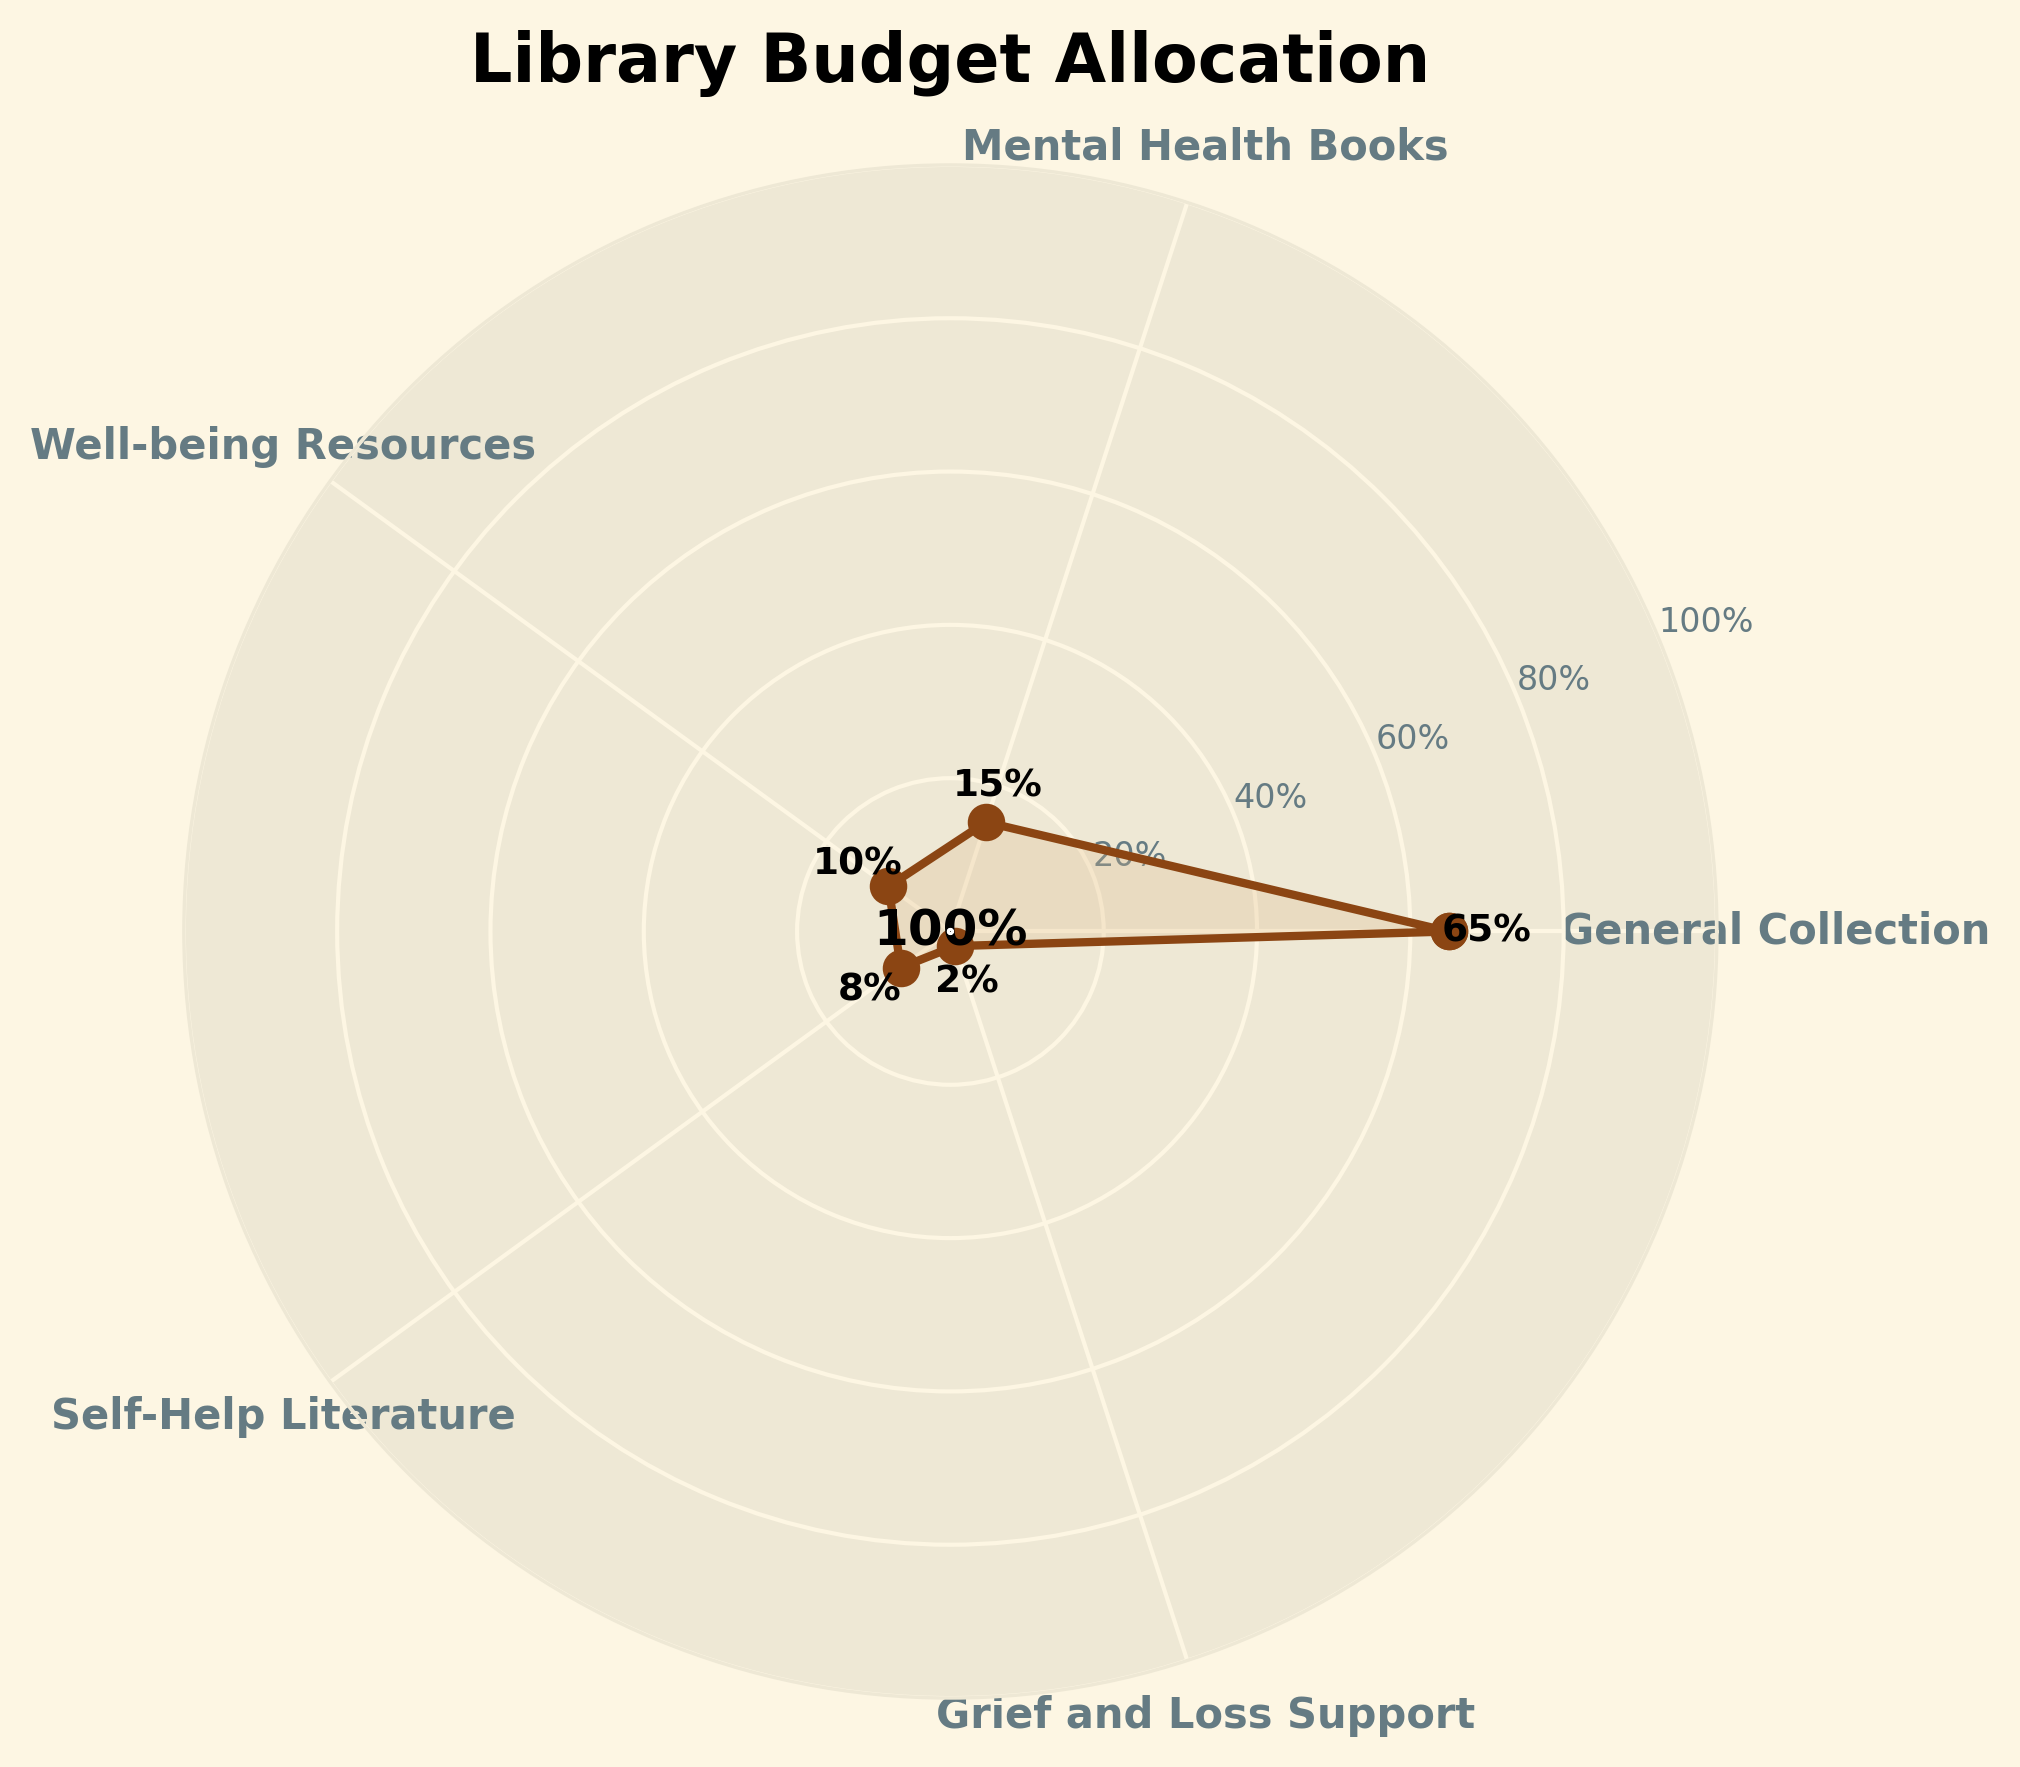What percentage of the library's budget is allocated to Mental Health Books? According to the figure, the percentage label next to "Mental Health Books" indicates the budget allocation.
Answer: 15% How much of the budget is allocated to Self-Help Literature compared to Grief and Loss Support? By comparing the percentage labels for Self-Help Literature (8%) and Grief and Loss Support (2%), we see that Self-Help Literature receives a greater percentage.
Answer: 6% more What is the total percentage of the budget allocated to categories specifically related to mental health and well-being? Sum the percentages for Mental Health Books (15%), Well-being Resources (10%), Self-Help Literature (8%), and Grief and Loss Support (2%). The total is \( 15 + 10 + 8 + 2 = 35 \)%
Answer: 35% Which category receives the majority of the library's budget? The figure shows that the category with the highest percentage label is the General Collection, which is 65%.
Answer: General Collection What is the smallest budget allocation category, and what percentage does it receive? According to the figure, the smallest percentage label is next to "Grief and Loss Support" at 2%.
Answer: Grief and Loss Support, 2% How does the allocation for Well-being Resources compare to that for Mental Health Books? By comparing the percentages, Well-being Resources (10%) receives 5% less than Mental Health Books (15%).
Answer: 5% less Which two categories have the closest budget allocations? By comparing the percentages, the closest figures are for Self-Help Literature (8%) and Well-being Resources (10%), a difference of 2%.
Answer: Self-Help Literature and Well-being Resources If we double the percentage of the Grief and Loss Support, how would it compare to the percentage for Self-Help Literature? Doubling Grief and Loss Support \(2 \times 2 = 4\)% would still be less than the Self-Help Literature's 8%.
Answer: Still less What is the angle in radians for well-being resources if the total allocation is represented in a 2π radians circle? The angle for Well-being Resources is calculated as \( \frac{10}{100} \times 2\pi = 0.2\pi \) radians.
Answer: \(0.2\pi\) Based on the visual elements, where is the overall budget percentage marked on the chart? The circular label inside the plot indicates the sum of all percentages, positioned at the center of the axes.
Answer: Center of the axes 